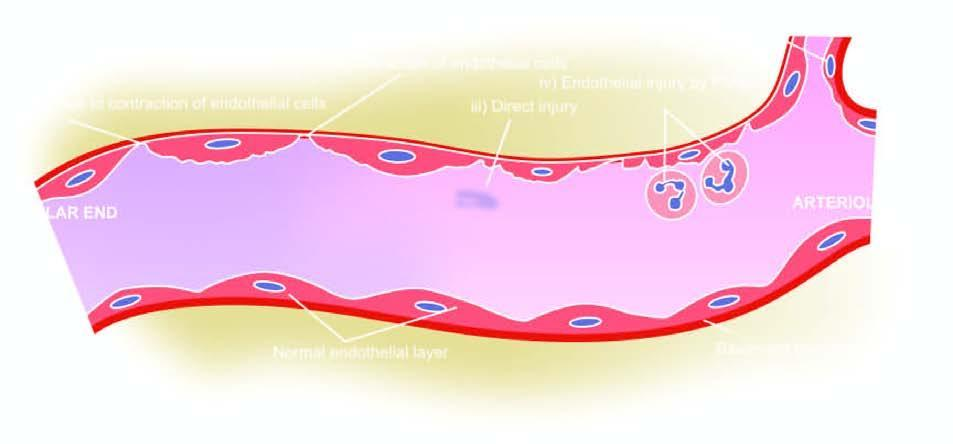do the serial numbers in the figure correspond to five numbers in the text?
Answer the question using a single word or phrase. Yes 